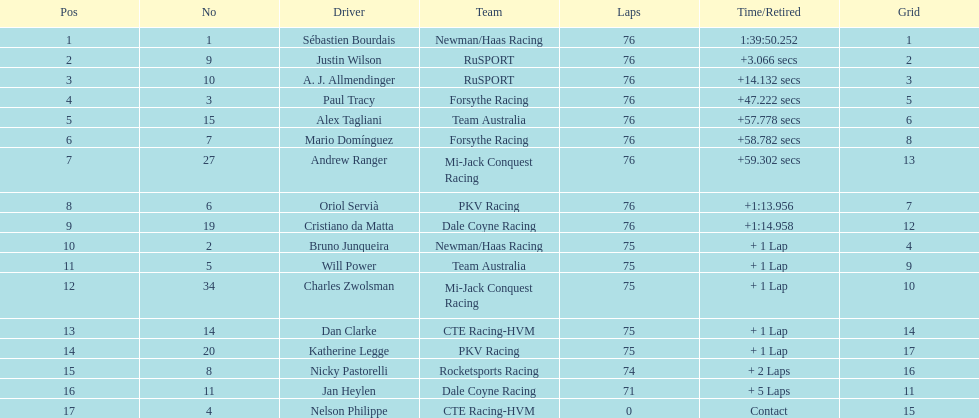Which driver has the least amount of points? Nelson Philippe. 